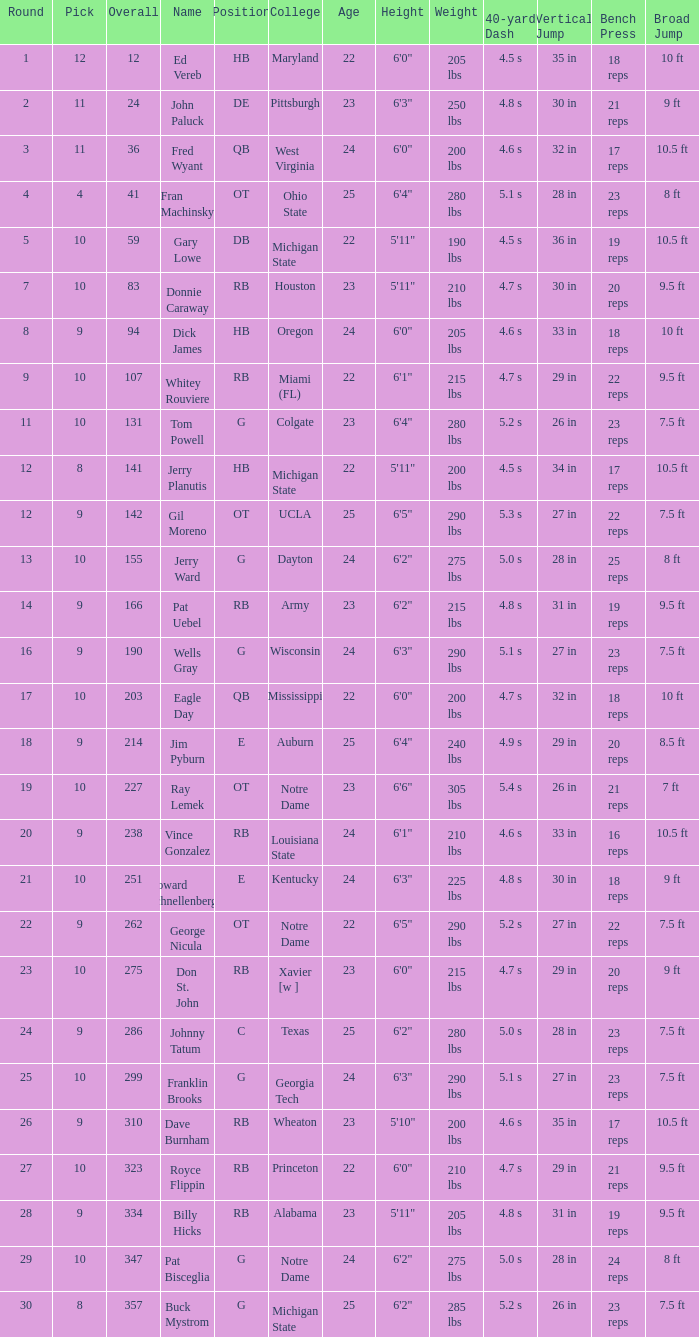What is the highest round number for donnie caraway? 7.0. 